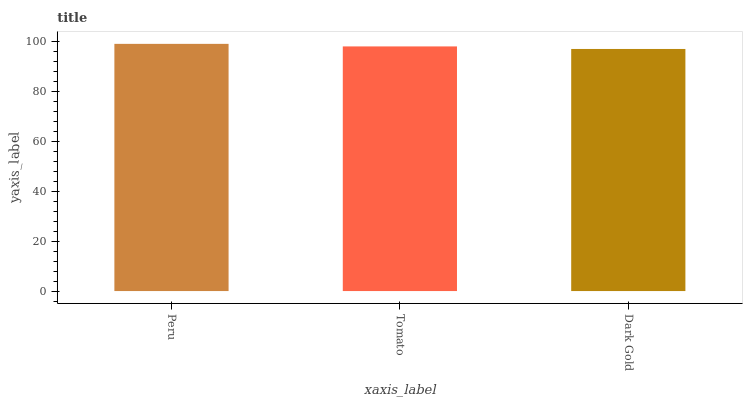Is Dark Gold the minimum?
Answer yes or no. Yes. Is Peru the maximum?
Answer yes or no. Yes. Is Tomato the minimum?
Answer yes or no. No. Is Tomato the maximum?
Answer yes or no. No. Is Peru greater than Tomato?
Answer yes or no. Yes. Is Tomato less than Peru?
Answer yes or no. Yes. Is Tomato greater than Peru?
Answer yes or no. No. Is Peru less than Tomato?
Answer yes or no. No. Is Tomato the high median?
Answer yes or no. Yes. Is Tomato the low median?
Answer yes or no. Yes. Is Peru the high median?
Answer yes or no. No. Is Dark Gold the low median?
Answer yes or no. No. 